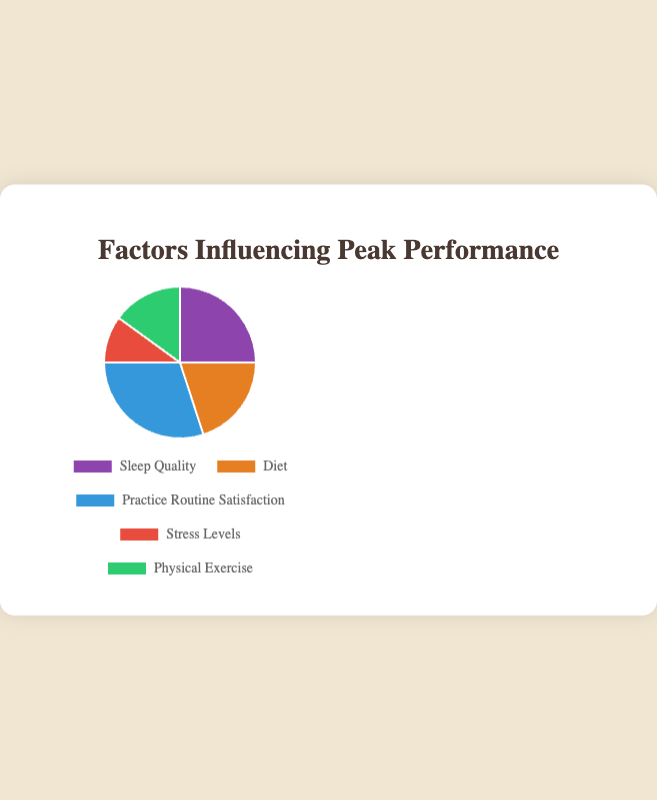What percentage of the pie chart is attributed to Diet and Physical Exercise combined? First, retrieve the values for Diet and Physical Exercise, which are 20 and 15 respectively. Add these values together: 20 + 15 = 35. This sum represents 35% of the pie chart.
Answer: 35 Which factor contributes the least to the pie chart? The segments of the pie chart represent different contributions, and by observing their values, it is evident that Stress Levels, with 10%, is the smallest contributor.
Answer: Stress Levels Is the value of Practice Routine Satisfaction greater than the sum of Stress Levels and Physical Exercise? First, calculate the sum of Stress Levels and Physical Exercise: 10 + 15 = 25. Then, compare this sum with the value of Practice Routine Satisfaction, which is 30. Since 30 > 25, the answer is yes.
Answer: Yes How much more does Sleep Quality contribute compared to Stress Levels? Look at the values for Sleep Quality and Stress Levels, which are 25 and 10 respectively. Subtract the value of Stress Levels from Sleep Quality: 25 - 10 = 15. So, Sleep Quality contributes 15% more than Stress Levels.
Answer: 15 Which factor has the highest contribution and what is its percentage? Observing the values, Practice Routine Satisfaction has the highest value at 30%.
Answer: Practice Routine Satisfaction, 30% What is the total percentage contributed by Sleep Quality, Diet, and Physical Exercise? Retrieve the values for Sleep Quality, Diet, and Physical Exercise, which are 25, 20, and 15 respectively. Add these values together: 25 + 20 + 15 = 60. This sum represents 60% of the pie chart.
Answer: 60 What is the difference in percentage between the highest contributing factor and the lowest contributing factor? The highest contributing factor is Practice Routine Satisfaction at 30%, and the lowest is Stress Levels at 10%. The difference is 30 - 10 = 20.
Answer: 20 Which segment is represented by the green color? By visual inspection, the green color segment represents Physical Exercise.
Answer: Physical Exercise 